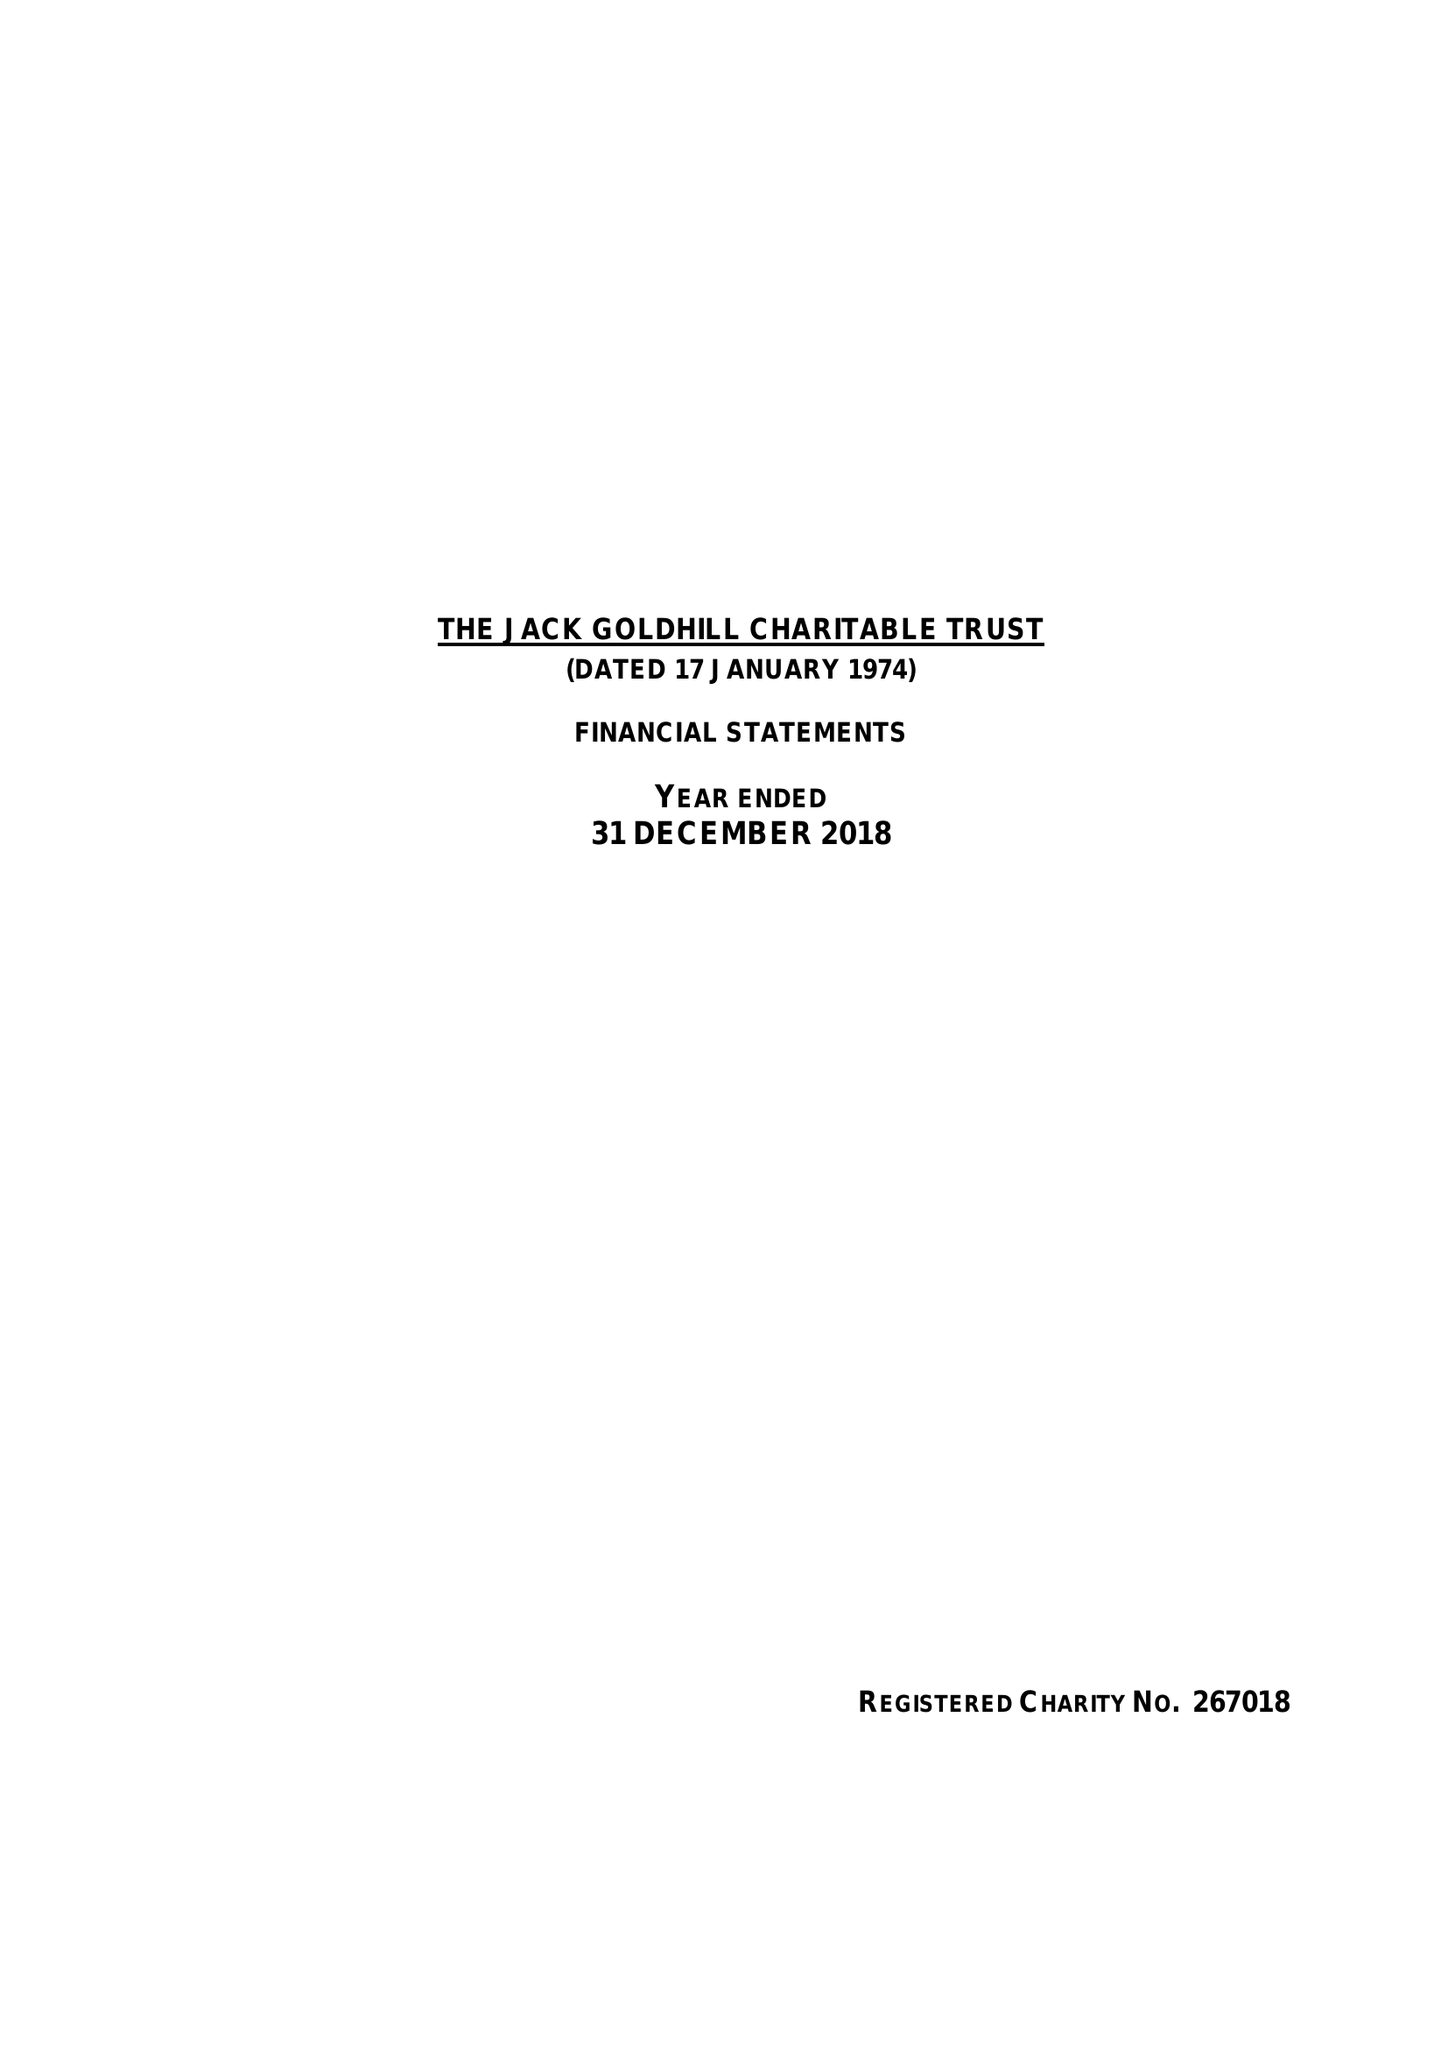What is the value for the address__street_line?
Answer the question using a single word or phrase. 1 DUCHESS STREET 